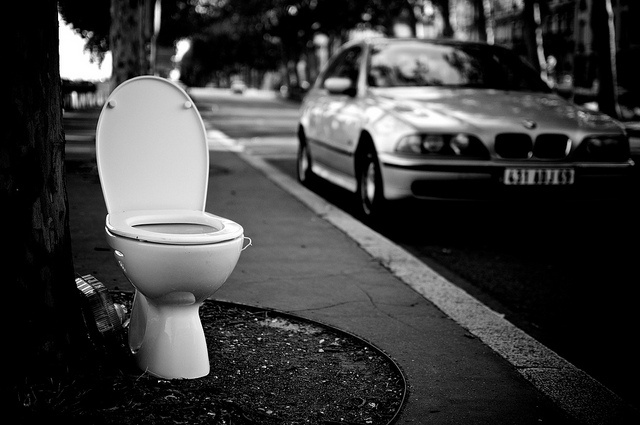Describe the objects in this image and their specific colors. I can see car in black, gray, darkgray, and lightgray tones, toilet in black, lightgray, darkgray, and gray tones, and car in darkgray, gray, lightgray, and black tones in this image. 